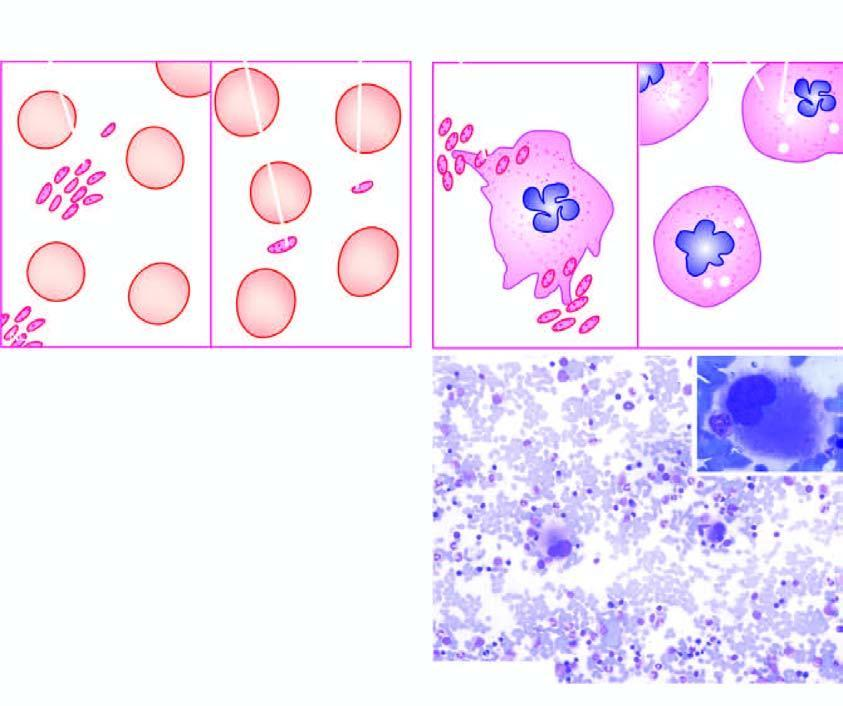does uppurative diseases show characteristically increased number of megakaryocytes with single non-lobulated nuclei and reduced cytoplasmic granularity inbox on right photomicrograph?
Answer the question using a single word or phrase. No 